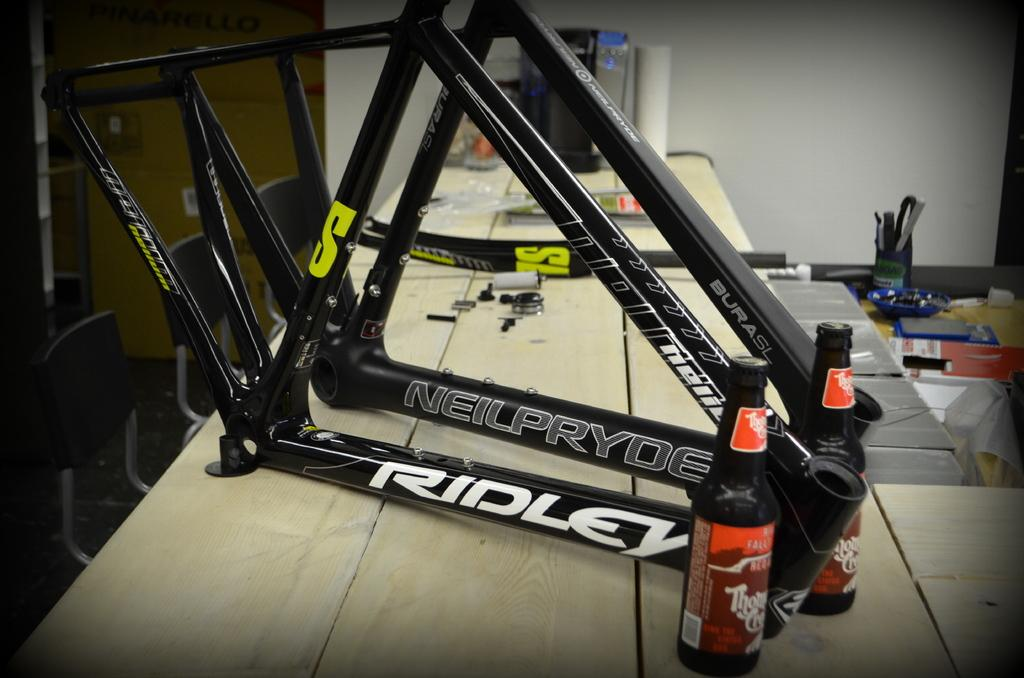What piece of furniture is present in the image? There is a table in the image. What objects are placed on the table? There are two bottles on the table. How many chairs are positioned near the table? There are three chairs beside the table. What color is the wall visible in the image? The wall in the image is white. What is the price of the drink in the image? There is no drink present in the image, so it is not possible to determine its price. 